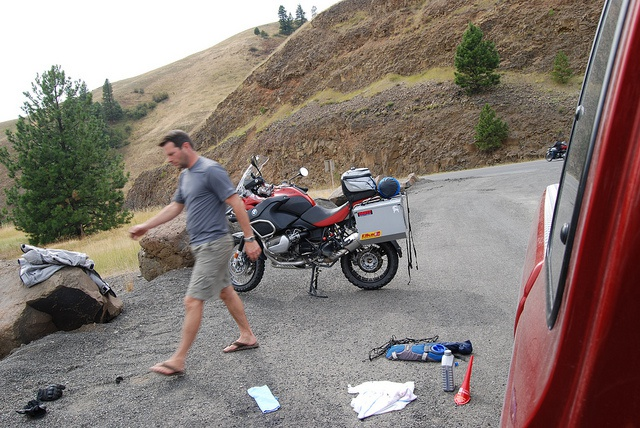Describe the objects in this image and their specific colors. I can see truck in white, maroon, black, brown, and darkgray tones, motorcycle in white, black, gray, darkgray, and lightgray tones, people in white, gray, and darkgray tones, handbag in white, black, lightgray, darkgray, and gray tones, and backpack in white, black, lavender, darkgray, and gray tones in this image. 